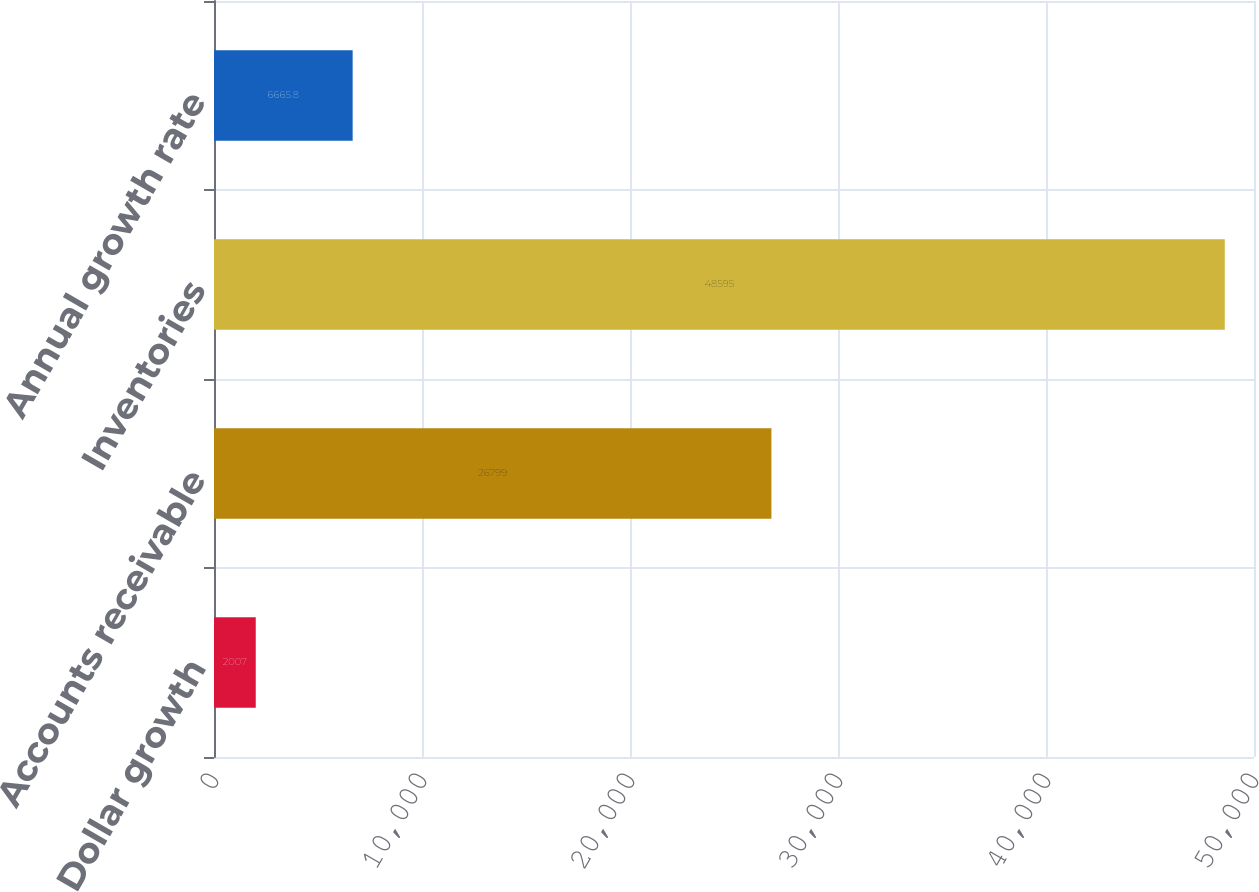<chart> <loc_0><loc_0><loc_500><loc_500><bar_chart><fcel>Dollar growth<fcel>Accounts receivable<fcel>Inventories<fcel>Annual growth rate<nl><fcel>2007<fcel>26799<fcel>48595<fcel>6665.8<nl></chart> 